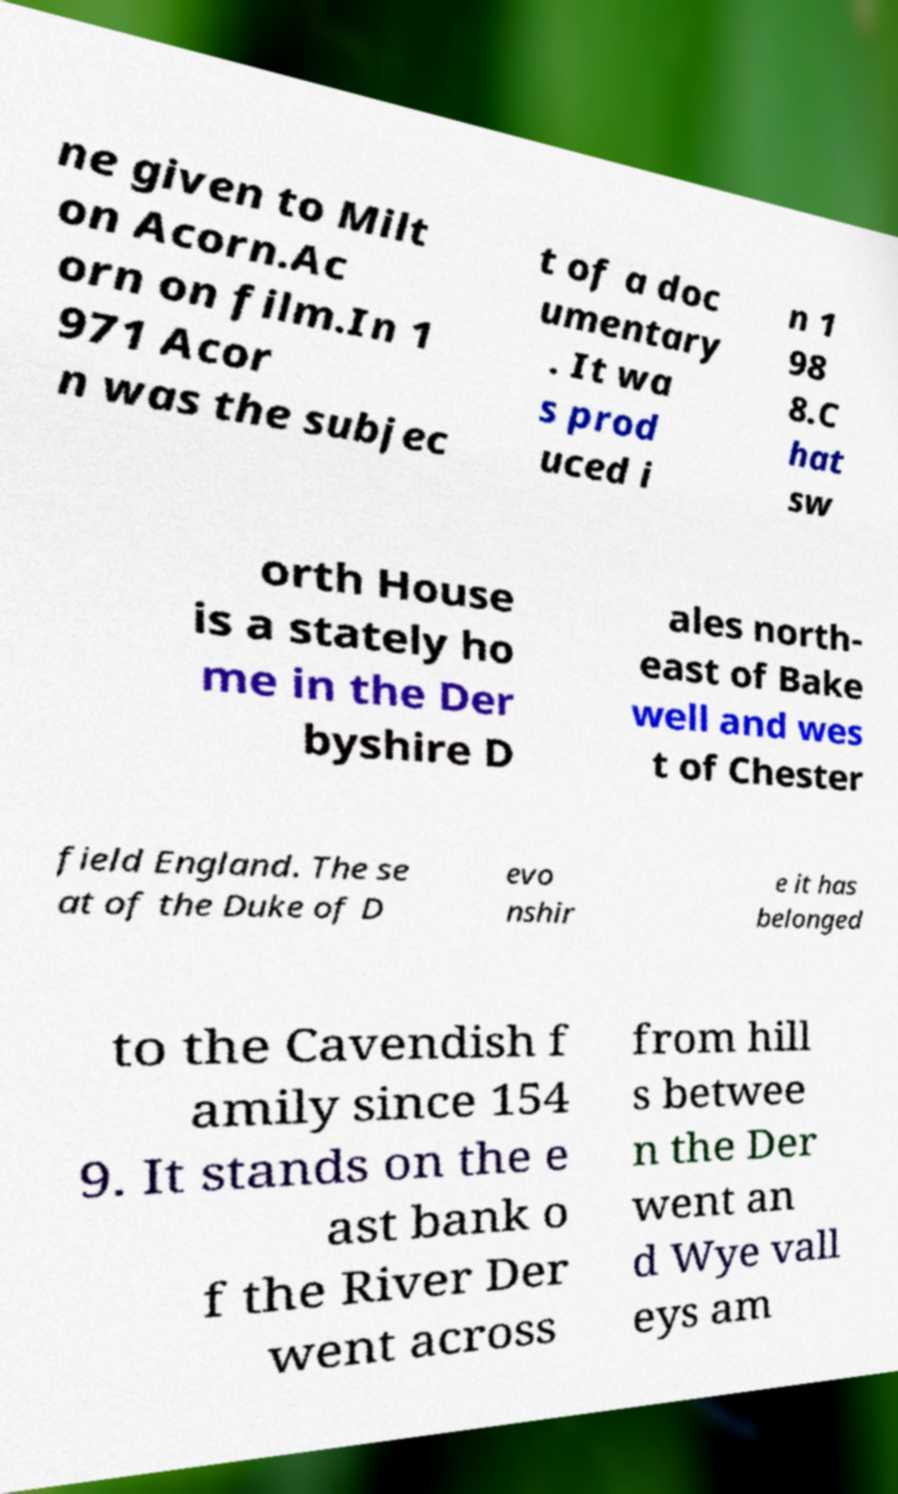Could you assist in decoding the text presented in this image and type it out clearly? ne given to Milt on Acorn.Ac orn on film.In 1 971 Acor n was the subjec t of a doc umentary . It wa s prod uced i n 1 98 8.C hat sw orth House is a stately ho me in the Der byshire D ales north- east of Bake well and wes t of Chester field England. The se at of the Duke of D evo nshir e it has belonged to the Cavendish f amily since 154 9. It stands on the e ast bank o f the River Der went across from hill s betwee n the Der went an d Wye vall eys am 